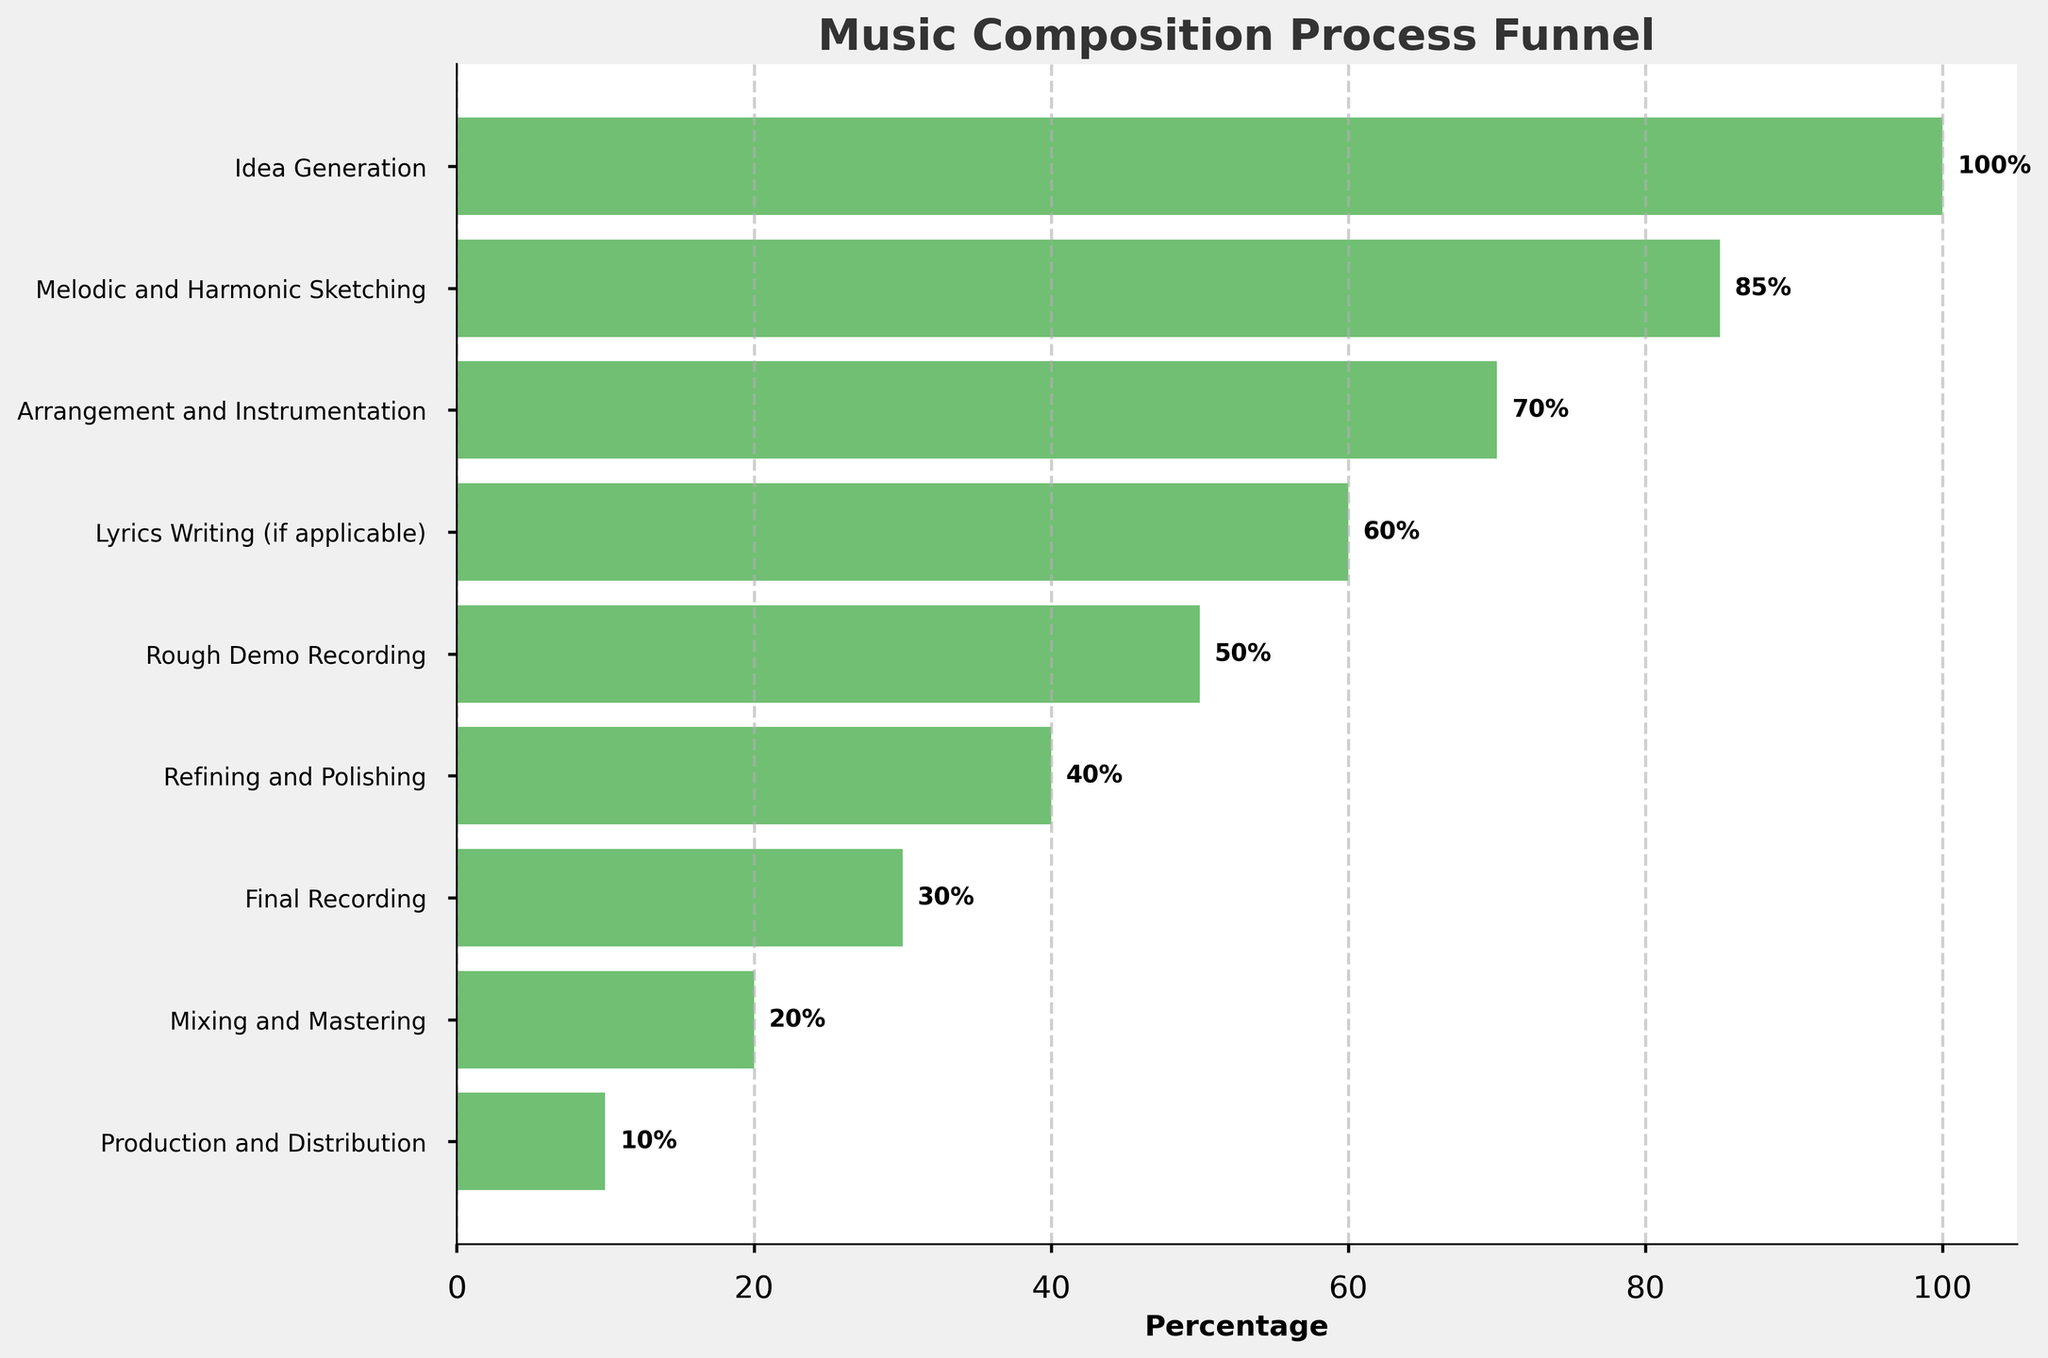What is the title of the funnel chart? The title is usually placed at the top of the chart to give context about what the chart is showing. In this case, it tells us what process the stages represent.
Answer: Music Composition Process Funnel Which stage has the highest percentage? To find the stage with the highest percentage, look at the first bar at the top, as the funnel progresses downwards decreasing in percentage.
Answer: Idea Generation How many stages are there in the music composition process funnel? Count the number of horizontal bars or tick labels on the y-axis. Each label represents a stage.
Answer: 9 At which stage does the percentage drop below 50%? Observe the order of stages by percentage. The stage immediately after the one with a 50% percentage will be where the drop occurs.
Answer: Refining and Polishing What is the difference in percentage between 'Arrangement and Instrumentation' and 'Final Recording'? Find the percentages for both stages ('Arrangement and Instrumentation' with 70% and 'Final Recording' with 30%), then subtract the smaller percentage from the larger one: 70% - 30% = 40%.
Answer: 40% How much percent decrease is there from 'Idea Generation' to 'Production and Distribution'? Subtract the percentage of 'Production and Distribution' from 'Idea Generation': 100% - 10% = 90%.
Answer: 90% Which stage has a 20% percentage? Look for the stage in the funnel that has a percentage of 20%, which is close to the end of the funnel.
Answer: Mixing and Mastering Is the percentage for 'Rough Demo Recording' greater than 'Lyrics Writing (if applicable)'? Compare the percentages for both stages, 'Rough Demo Recording' with 50% and 'Lyrics Writing (if applicable)' with 60%.
Answer: No What percentage of the stages fall below 50%? Count the number of stages with percentages below 50%, then divide by the total number of stages and multiply by 100 to get the percentage: There are 5 stages out of 9 below 50%, (5/9)*100 ≈ 55.6%.
Answer: 55.6% Which stage comes immediately after 'Melodic and Harmonic Sketching'? Find 'Melodic and Harmonic Sketching' then look at the next stage listed below it in the funnel.
Answer: Arrangement and Instrumentation 